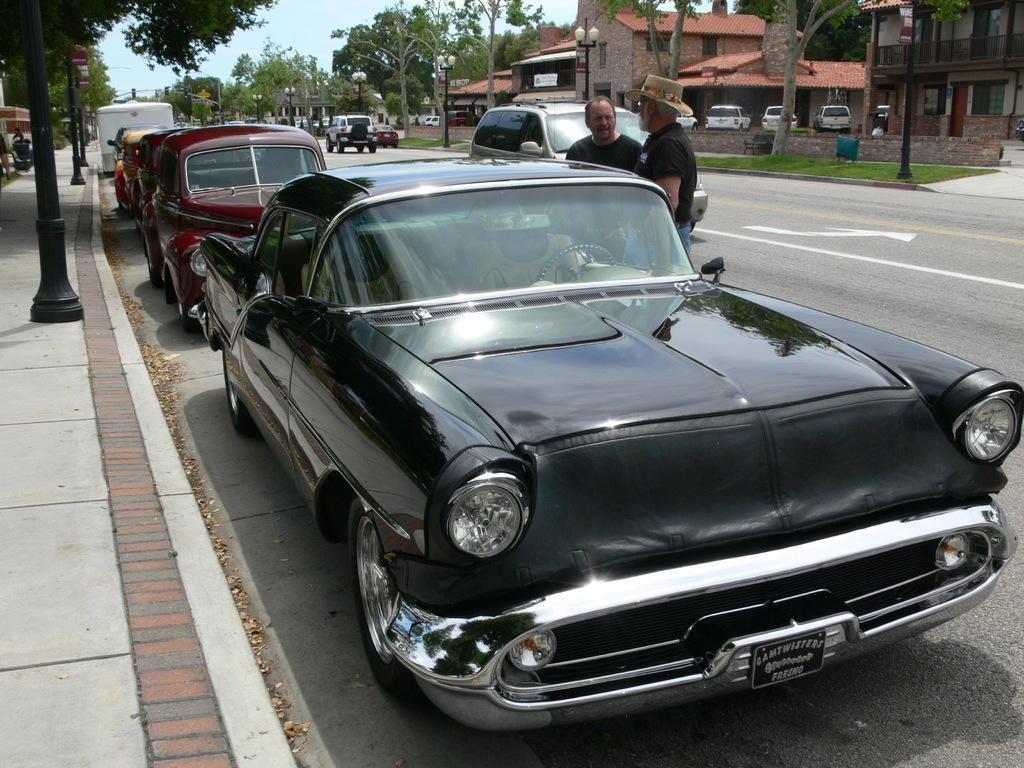Can you describe this image briefly? There are cars and two persons are standing on the road as we can see in the middle of this image. We can see trees and buildings in the background and the sky is at the top of this image. 